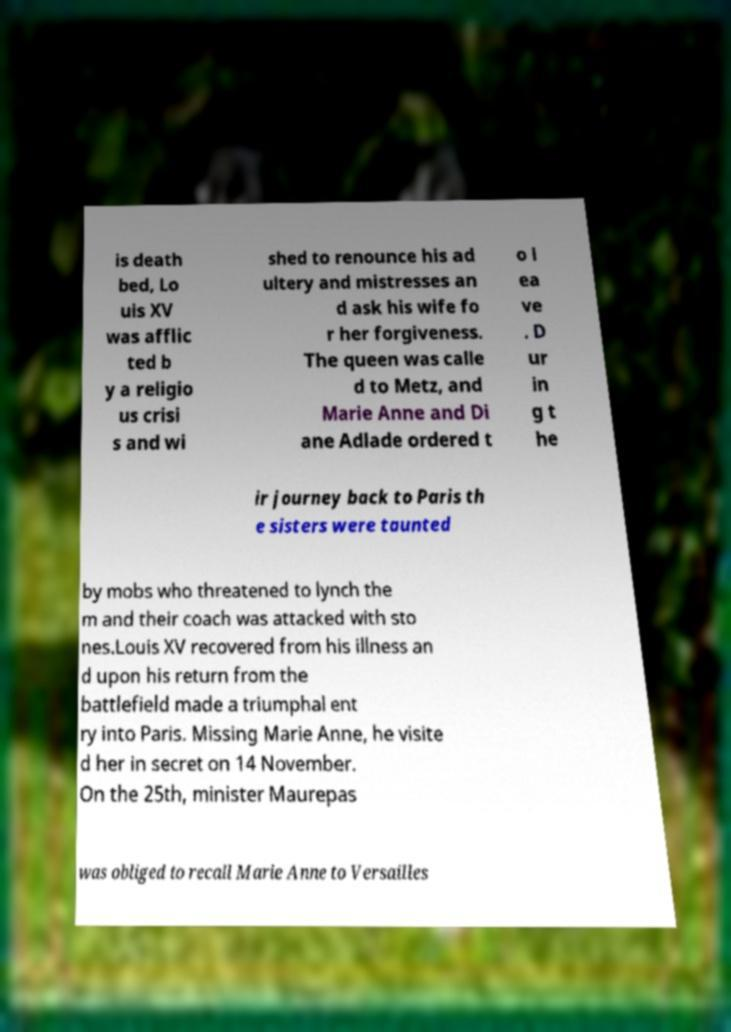Could you assist in decoding the text presented in this image and type it out clearly? is death bed, Lo uis XV was afflic ted b y a religio us crisi s and wi shed to renounce his ad ultery and mistresses an d ask his wife fo r her forgiveness. The queen was calle d to Metz, and Marie Anne and Di ane Adlade ordered t o l ea ve . D ur in g t he ir journey back to Paris th e sisters were taunted by mobs who threatened to lynch the m and their coach was attacked with sto nes.Louis XV recovered from his illness an d upon his return from the battlefield made a triumphal ent ry into Paris. Missing Marie Anne, he visite d her in secret on 14 November. On the 25th, minister Maurepas was obliged to recall Marie Anne to Versailles 